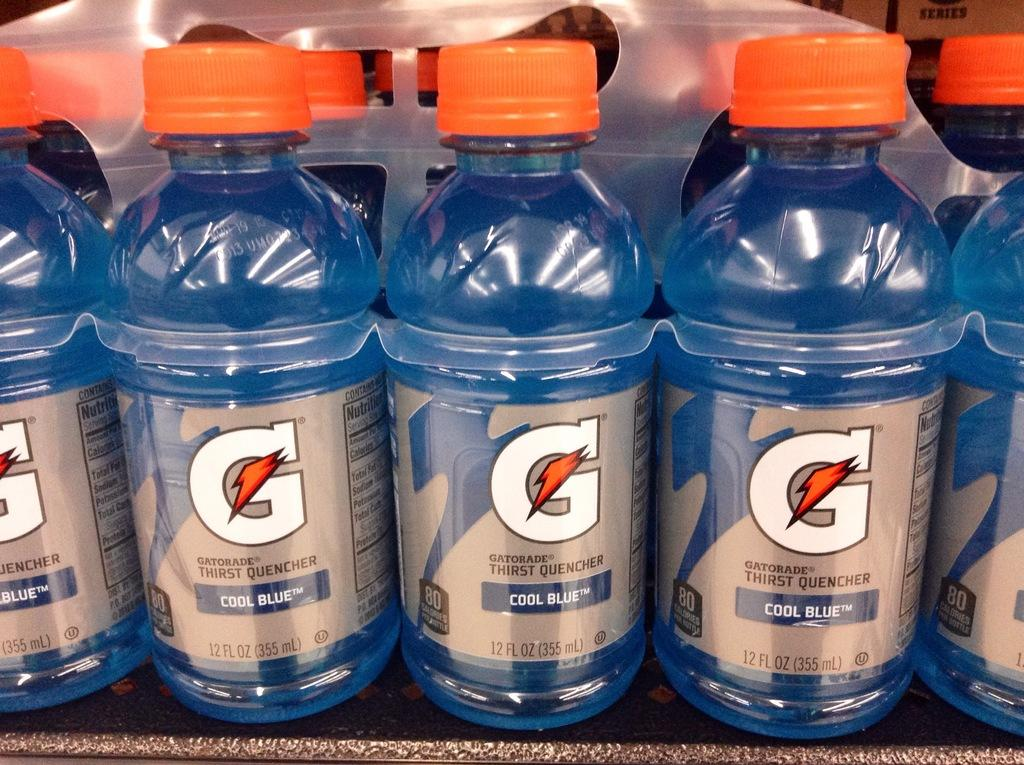<image>
Present a compact description of the photo's key features. Blue bottles of Gatorade sit in a row on a shelf. 